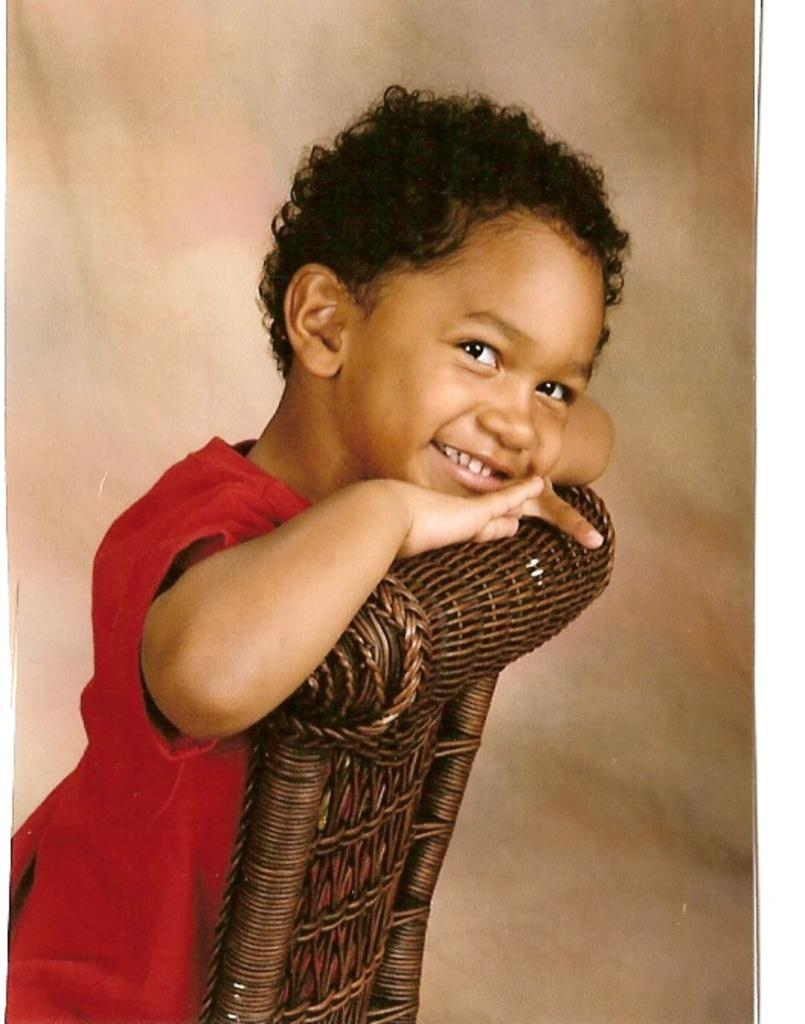What is the main subject of the image? The main subject of the image is a kid. What is the kid doing in the image? The kid is holding a chair and smiling. Can you describe the background of the image? The background of the image is blurred. What does the kid's grandmother desire in the image? There is no mention of a grandmother or any desires in the image. 